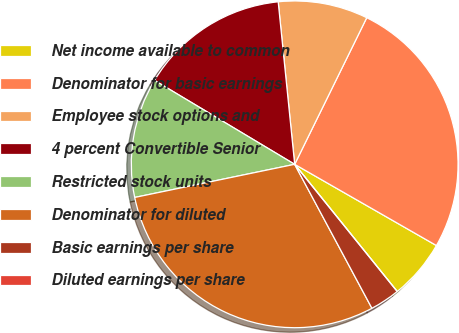<chart> <loc_0><loc_0><loc_500><loc_500><pie_chart><fcel>Net income available to common<fcel>Denominator for basic earnings<fcel>Employee stock options and<fcel>4 percent Convertible Senior<fcel>Restricted stock units<fcel>Denominator for diluted<fcel>Basic earnings per share<fcel>Diluted earnings per share<nl><fcel>5.92%<fcel>26.01%<fcel>8.88%<fcel>14.8%<fcel>11.84%<fcel>29.59%<fcel>2.96%<fcel>0.0%<nl></chart> 